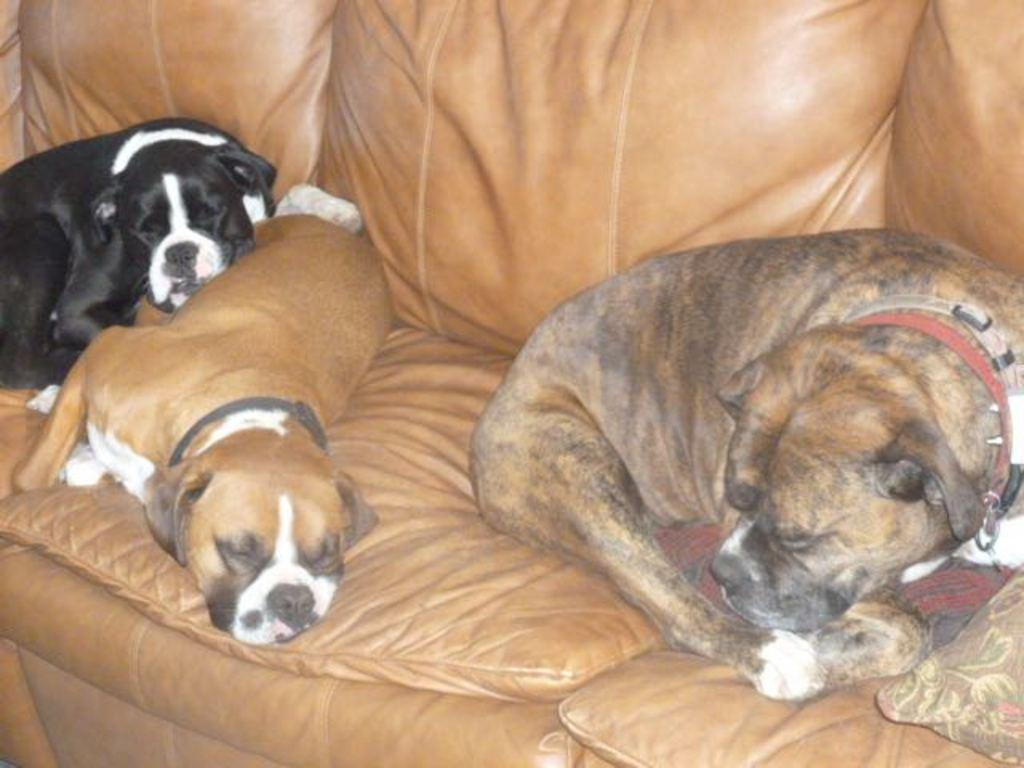How many dogs are present in the image? There are three dogs in the image. What are the dogs doing in the image? The dogs are sleeping on a brown color sofa. Can you describe any additional objects in the image? There is a pillow in the right bottom of the image. Are there any boys playing near the mailbox in the image? There is no mention of boys or a mailbox in the image; it features three dogs sleeping on a brown sofa and a pillow. 